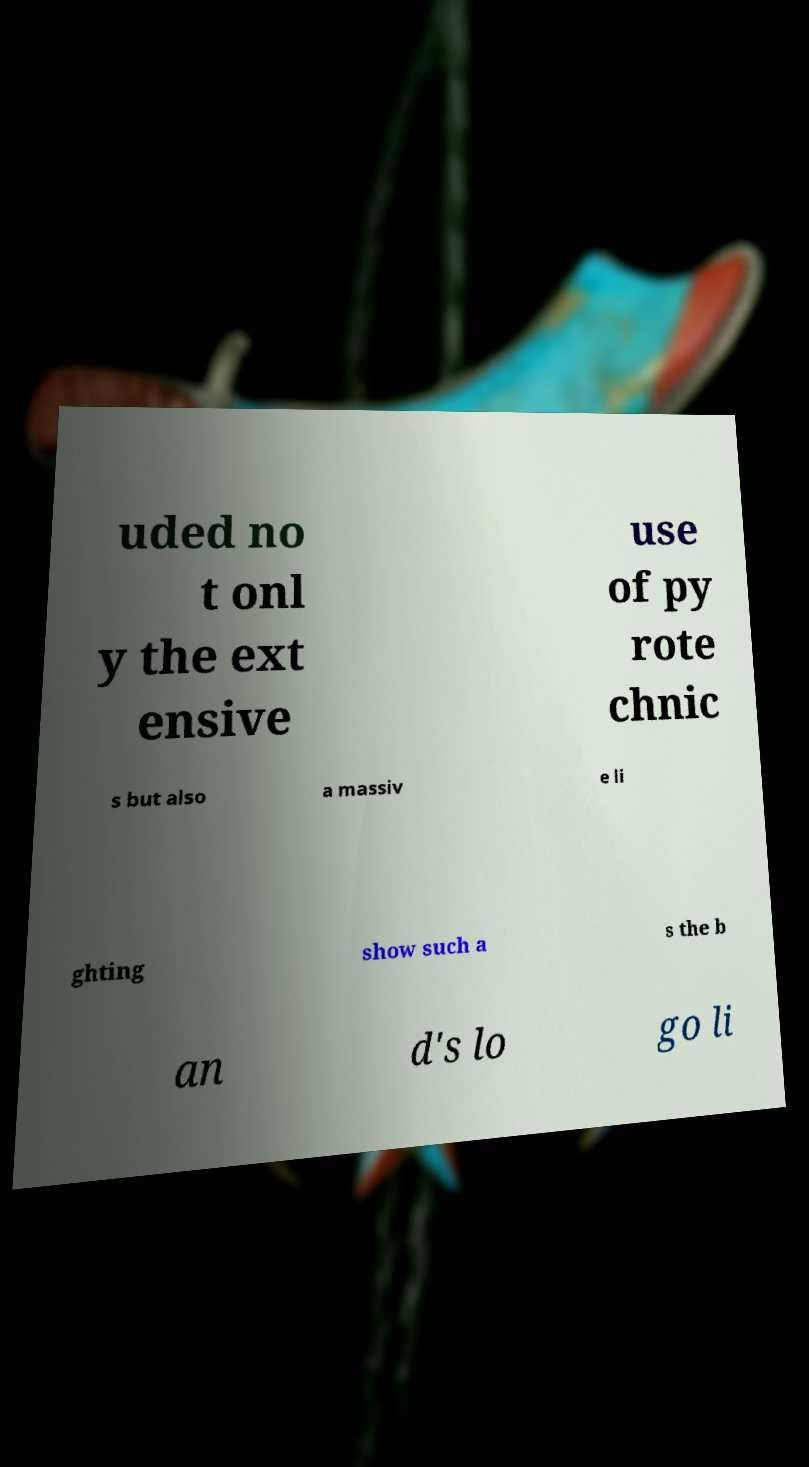Could you extract and type out the text from this image? uded no t onl y the ext ensive use of py rote chnic s but also a massiv e li ghting show such a s the b an d's lo go li 